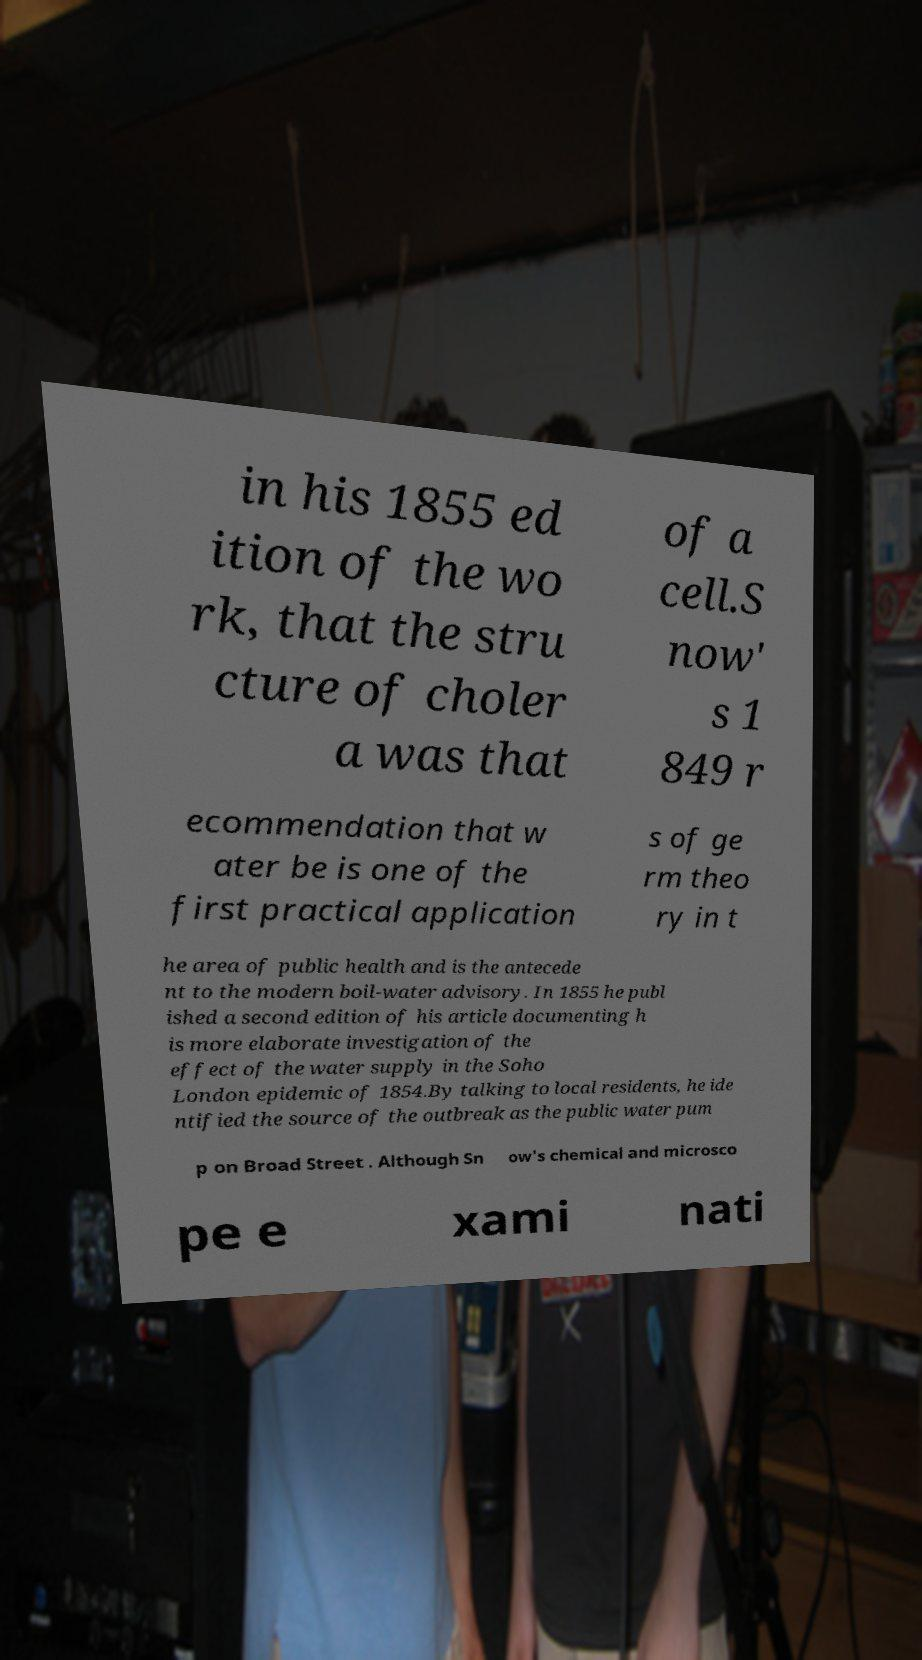What messages or text are displayed in this image? I need them in a readable, typed format. in his 1855 ed ition of the wo rk, that the stru cture of choler a was that of a cell.S now' s 1 849 r ecommendation that w ater be is one of the first practical application s of ge rm theo ry in t he area of public health and is the antecede nt to the modern boil-water advisory. In 1855 he publ ished a second edition of his article documenting h is more elaborate investigation of the effect of the water supply in the Soho London epidemic of 1854.By talking to local residents, he ide ntified the source of the outbreak as the public water pum p on Broad Street . Although Sn ow's chemical and microsco pe e xami nati 